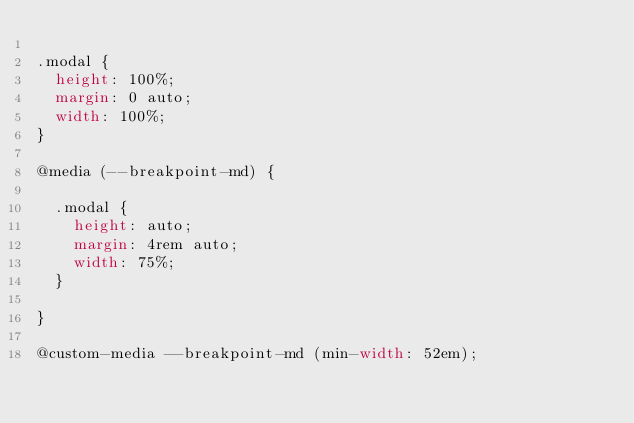<code> <loc_0><loc_0><loc_500><loc_500><_CSS_>
.modal {
  height: 100%;
  margin: 0 auto;
  width: 100%;
}

@media (--breakpoint-md) {

  .modal {
    height: auto;
    margin: 4rem auto;
    width: 75%;
  }

}

@custom-media --breakpoint-md (min-width: 52em);
</code> 